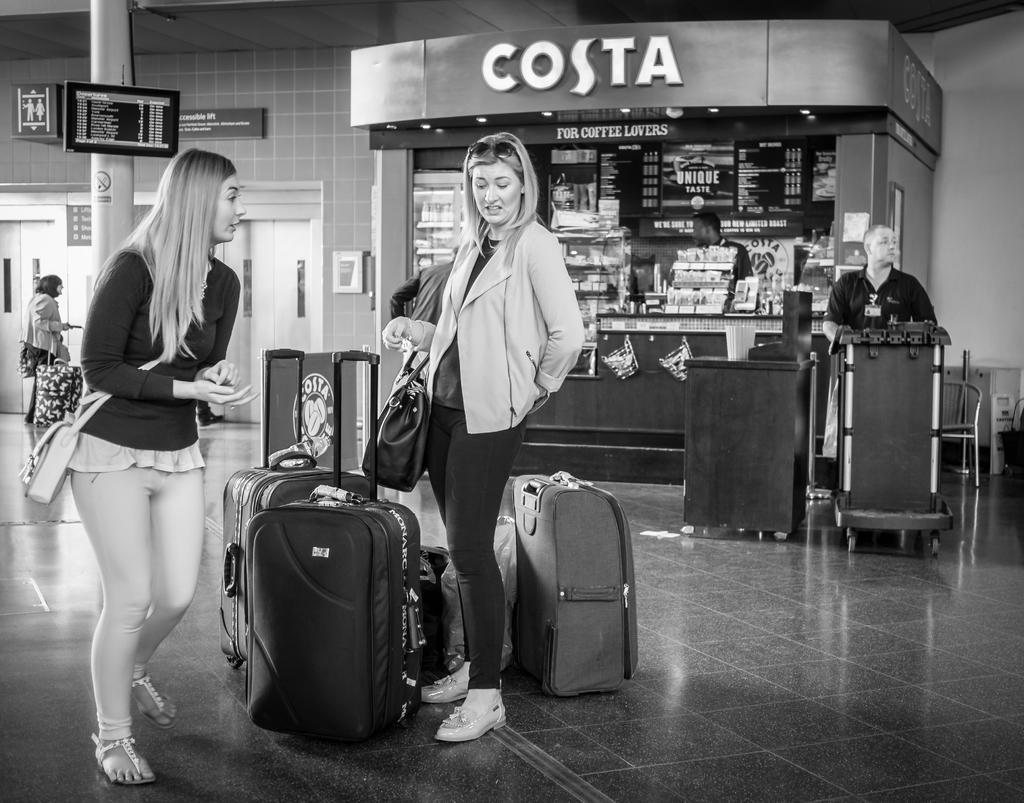How many women are in the image? There are two women in the image. What are the women holding or standing near? The women are standing near luggage bags in front of them. What can be seen in the background of the image? There is a coffee shop visible in the background. What type of location might this image be depicting? The setting appears to be an airport. What type of stream can be seen flowing through the coffee shop in the image? There is no stream visible in the image; the background features a coffee shop, but no stream is present. 